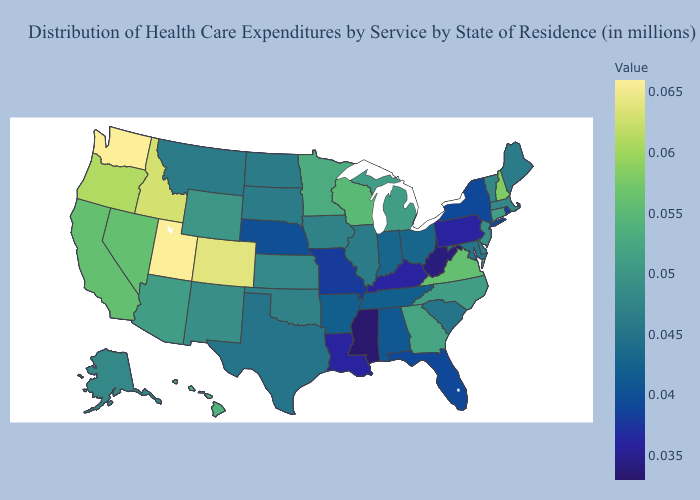Among the states that border Oklahoma , does Colorado have the lowest value?
Answer briefly. No. Does Wisconsin have the highest value in the MidWest?
Write a very short answer. Yes. Does Pennsylvania have the lowest value in the Northeast?
Be succinct. Yes. Does Kentucky have the lowest value in the South?
Answer briefly. No. Among the states that border Kentucky , does Virginia have the highest value?
Be succinct. Yes. 